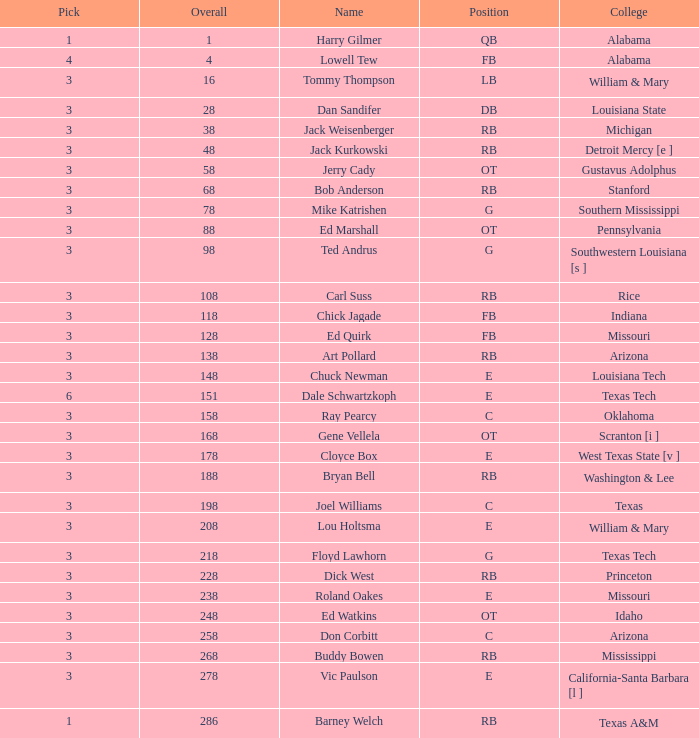Which selection has a round less than 8, and an overall less than 16, and a name of harry gilmer? 1.0. 